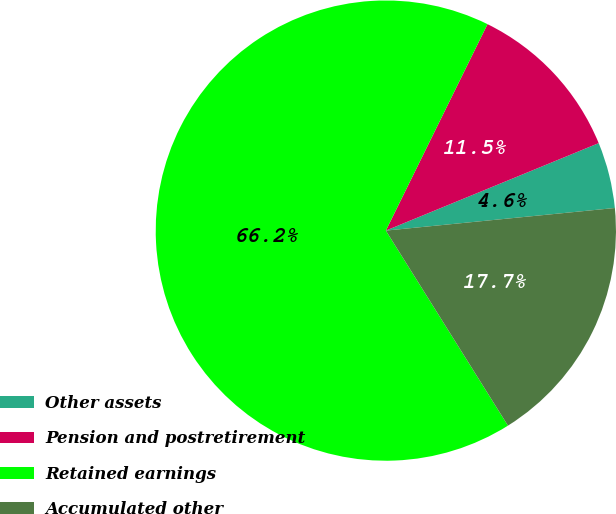Convert chart to OTSL. <chart><loc_0><loc_0><loc_500><loc_500><pie_chart><fcel>Other assets<fcel>Pension and postretirement<fcel>Retained earnings<fcel>Accumulated other<nl><fcel>4.64%<fcel>11.51%<fcel>66.18%<fcel>17.66%<nl></chart> 